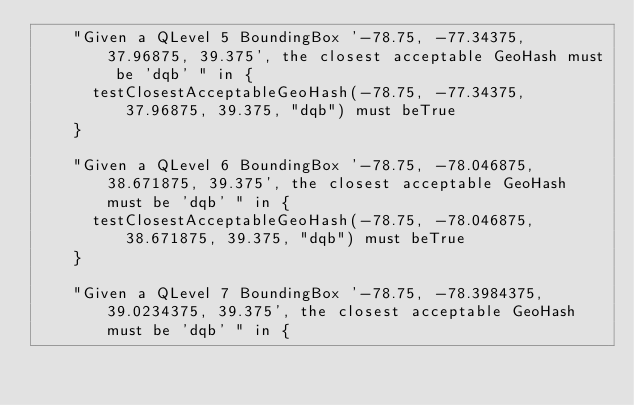Convert code to text. <code><loc_0><loc_0><loc_500><loc_500><_Scala_>    "Given a QLevel 5 BoundingBox '-78.75, -77.34375, 37.96875, 39.375', the closest acceptable GeoHash must be 'dqb' " in {
      testClosestAcceptableGeoHash(-78.75, -77.34375, 37.96875, 39.375, "dqb") must beTrue
    }

    "Given a QLevel 6 BoundingBox '-78.75, -78.046875, 38.671875, 39.375', the closest acceptable GeoHash must be 'dqb' " in {
      testClosestAcceptableGeoHash(-78.75, -78.046875, 38.671875, 39.375, "dqb") must beTrue
    }

    "Given a QLevel 7 BoundingBox '-78.75, -78.3984375, 39.0234375, 39.375', the closest acceptable GeoHash must be 'dqb' " in {</code> 